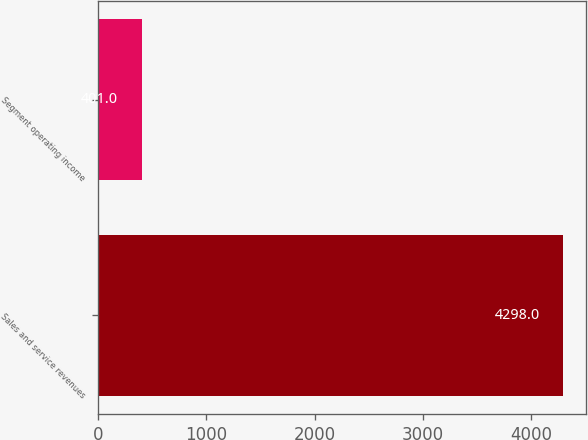<chart> <loc_0><loc_0><loc_500><loc_500><bar_chart><fcel>Sales and service revenues<fcel>Segment operating income<nl><fcel>4298<fcel>401<nl></chart> 